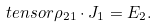Convert formula to latex. <formula><loc_0><loc_0><loc_500><loc_500>\ t e n s o r \rho _ { 2 1 } \cdot { J } _ { 1 } = { E } _ { 2 } .</formula> 